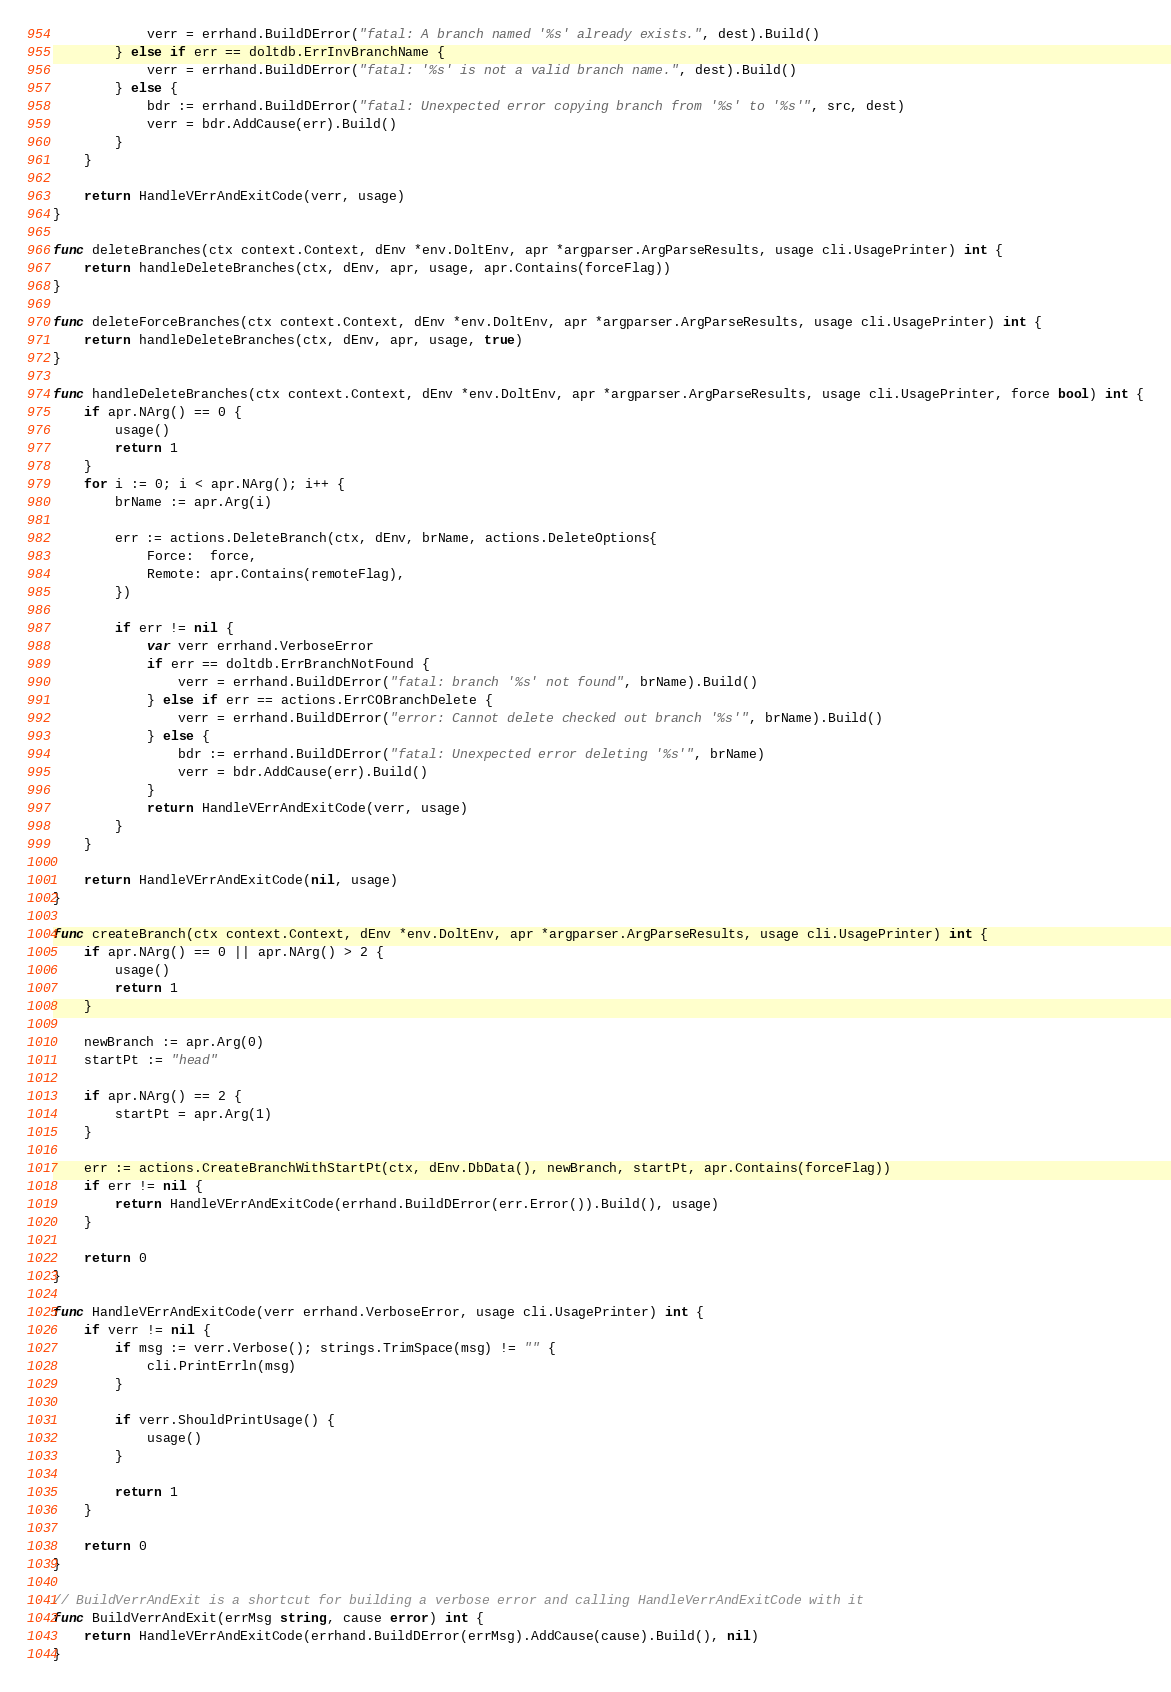Convert code to text. <code><loc_0><loc_0><loc_500><loc_500><_Go_>			verr = errhand.BuildDError("fatal: A branch named '%s' already exists.", dest).Build()
		} else if err == doltdb.ErrInvBranchName {
			verr = errhand.BuildDError("fatal: '%s' is not a valid branch name.", dest).Build()
		} else {
			bdr := errhand.BuildDError("fatal: Unexpected error copying branch from '%s' to '%s'", src, dest)
			verr = bdr.AddCause(err).Build()
		}
	}

	return HandleVErrAndExitCode(verr, usage)
}

func deleteBranches(ctx context.Context, dEnv *env.DoltEnv, apr *argparser.ArgParseResults, usage cli.UsagePrinter) int {
	return handleDeleteBranches(ctx, dEnv, apr, usage, apr.Contains(forceFlag))
}

func deleteForceBranches(ctx context.Context, dEnv *env.DoltEnv, apr *argparser.ArgParseResults, usage cli.UsagePrinter) int {
	return handleDeleteBranches(ctx, dEnv, apr, usage, true)
}

func handleDeleteBranches(ctx context.Context, dEnv *env.DoltEnv, apr *argparser.ArgParseResults, usage cli.UsagePrinter, force bool) int {
	if apr.NArg() == 0 {
		usage()
		return 1
	}
	for i := 0; i < apr.NArg(); i++ {
		brName := apr.Arg(i)

		err := actions.DeleteBranch(ctx, dEnv, brName, actions.DeleteOptions{
			Force:  force,
			Remote: apr.Contains(remoteFlag),
		})

		if err != nil {
			var verr errhand.VerboseError
			if err == doltdb.ErrBranchNotFound {
				verr = errhand.BuildDError("fatal: branch '%s' not found", brName).Build()
			} else if err == actions.ErrCOBranchDelete {
				verr = errhand.BuildDError("error: Cannot delete checked out branch '%s'", brName).Build()
			} else {
				bdr := errhand.BuildDError("fatal: Unexpected error deleting '%s'", brName)
				verr = bdr.AddCause(err).Build()
			}
			return HandleVErrAndExitCode(verr, usage)
		}
	}

	return HandleVErrAndExitCode(nil, usage)
}

func createBranch(ctx context.Context, dEnv *env.DoltEnv, apr *argparser.ArgParseResults, usage cli.UsagePrinter) int {
	if apr.NArg() == 0 || apr.NArg() > 2 {
		usage()
		return 1
	}

	newBranch := apr.Arg(0)
	startPt := "head"

	if apr.NArg() == 2 {
		startPt = apr.Arg(1)
	}

	err := actions.CreateBranchWithStartPt(ctx, dEnv.DbData(), newBranch, startPt, apr.Contains(forceFlag))
	if err != nil {
		return HandleVErrAndExitCode(errhand.BuildDError(err.Error()).Build(), usage)
	}

	return 0
}

func HandleVErrAndExitCode(verr errhand.VerboseError, usage cli.UsagePrinter) int {
	if verr != nil {
		if msg := verr.Verbose(); strings.TrimSpace(msg) != "" {
			cli.PrintErrln(msg)
		}

		if verr.ShouldPrintUsage() {
			usage()
		}

		return 1
	}

	return 0
}

// BuildVerrAndExit is a shortcut for building a verbose error and calling HandleVerrAndExitCode with it
func BuildVerrAndExit(errMsg string, cause error) int {
	return HandleVErrAndExitCode(errhand.BuildDError(errMsg).AddCause(cause).Build(), nil)
}
</code> 